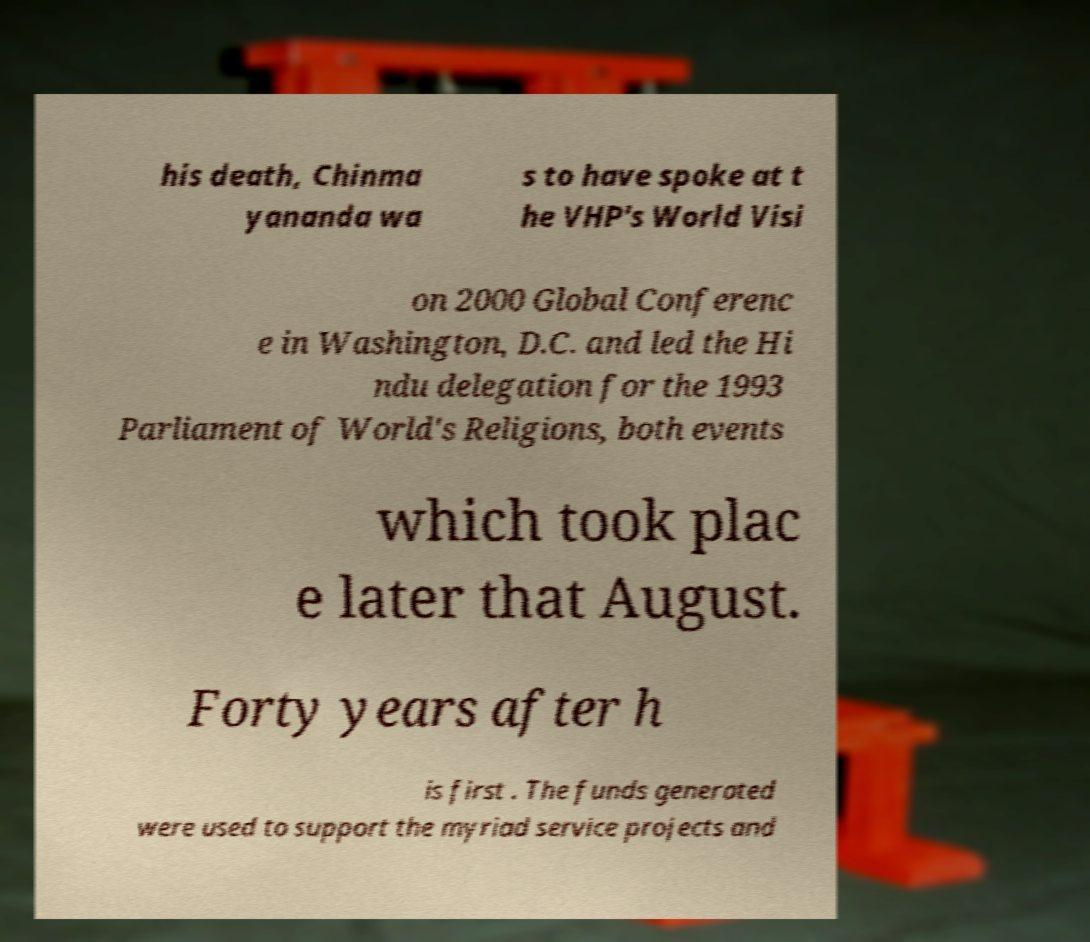Can you accurately transcribe the text from the provided image for me? his death, Chinma yananda wa s to have spoke at t he VHP's World Visi on 2000 Global Conferenc e in Washington, D.C. and led the Hi ndu delegation for the 1993 Parliament of World's Religions, both events which took plac e later that August. Forty years after h is first . The funds generated were used to support the myriad service projects and 